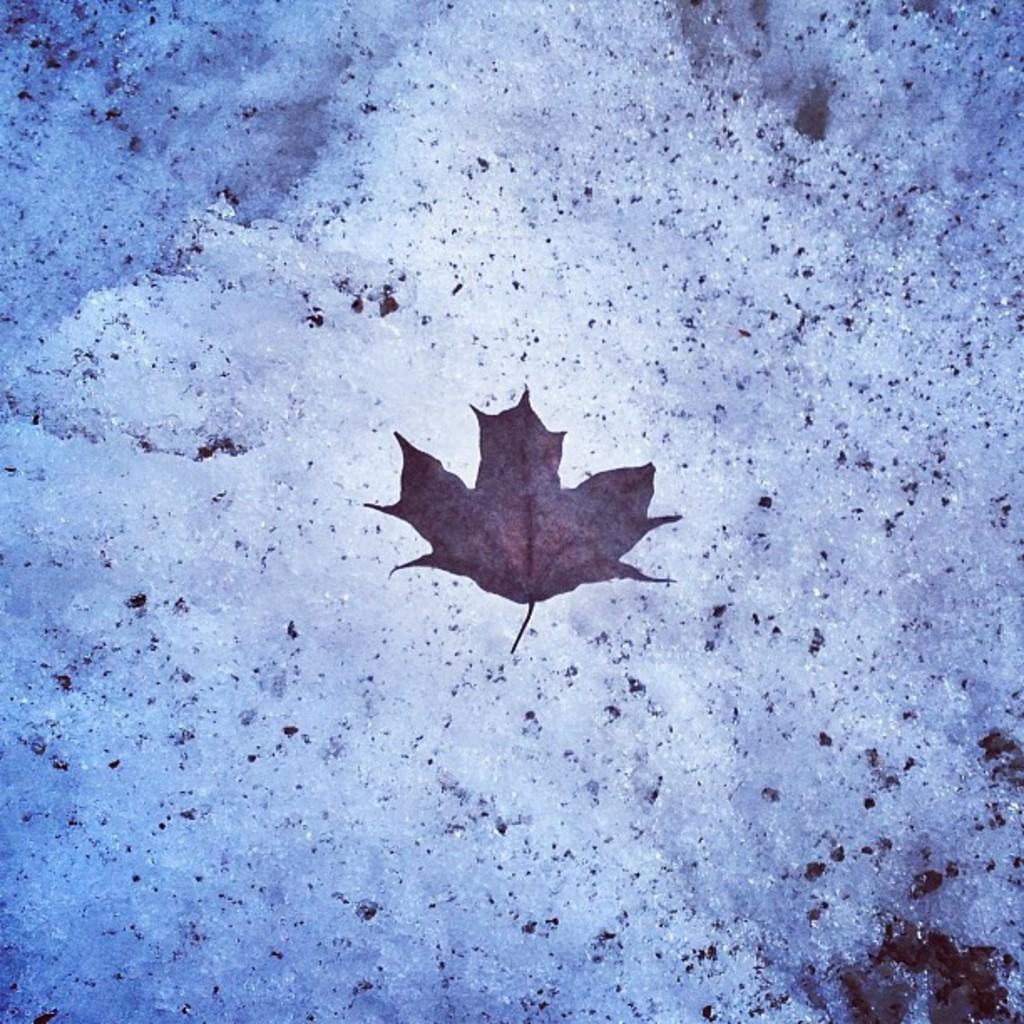What is the main subject in the center of the image? There is a dry leaf in the center of the image. What can be seen in the background of the image? There is ice visible in the background of the image. How many clovers are growing around the dry leaf in the image? There are no clovers visible in the image; it only features a dry leaf and ice in the background. 